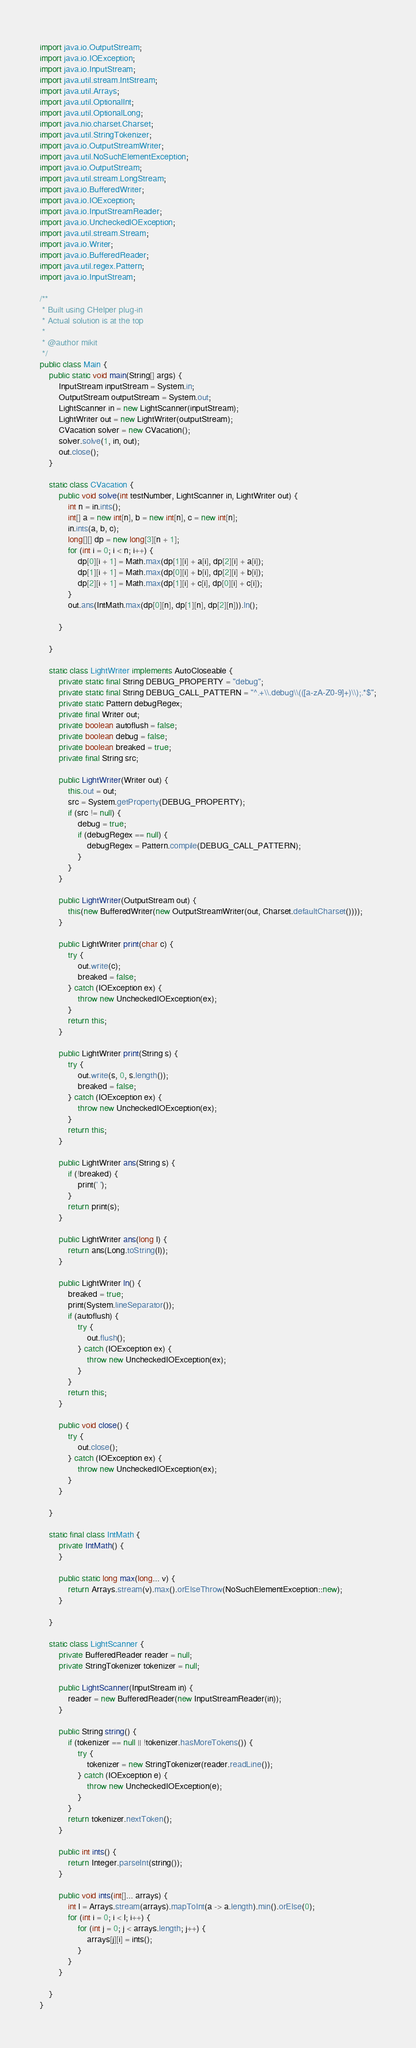<code> <loc_0><loc_0><loc_500><loc_500><_Java_>import java.io.OutputStream;
import java.io.IOException;
import java.io.InputStream;
import java.util.stream.IntStream;
import java.util.Arrays;
import java.util.OptionalInt;
import java.util.OptionalLong;
import java.nio.charset.Charset;
import java.util.StringTokenizer;
import java.io.OutputStreamWriter;
import java.util.NoSuchElementException;
import java.io.OutputStream;
import java.util.stream.LongStream;
import java.io.BufferedWriter;
import java.io.IOException;
import java.io.InputStreamReader;
import java.io.UncheckedIOException;
import java.util.stream.Stream;
import java.io.Writer;
import java.io.BufferedReader;
import java.util.regex.Pattern;
import java.io.InputStream;

/**
 * Built using CHelper plug-in
 * Actual solution is at the top
 *
 * @author mikit
 */
public class Main {
    public static void main(String[] args) {
        InputStream inputStream = System.in;
        OutputStream outputStream = System.out;
        LightScanner in = new LightScanner(inputStream);
        LightWriter out = new LightWriter(outputStream);
        CVacation solver = new CVacation();
        solver.solve(1, in, out);
        out.close();
    }

    static class CVacation {
        public void solve(int testNumber, LightScanner in, LightWriter out) {
            int n = in.ints();
            int[] a = new int[n], b = new int[n], c = new int[n];
            in.ints(a, b, c);
            long[][] dp = new long[3][n + 1];
            for (int i = 0; i < n; i++) {
                dp[0][i + 1] = Math.max(dp[1][i] + a[i], dp[2][i] + a[i]);
                dp[1][i + 1] = Math.max(dp[0][i] + b[i], dp[2][i] + b[i]);
                dp[2][i + 1] = Math.max(dp[1][i] + c[i], dp[0][i] + c[i]);
            }
            out.ans(IntMath.max(dp[0][n], dp[1][n], dp[2][n])).ln();

        }

    }

    static class LightWriter implements AutoCloseable {
        private static final String DEBUG_PROPERTY = "debug";
        private static final String DEBUG_CALL_PATTERN = "^.+\\.debug\\(([a-zA-Z0-9]+)\\);.*$";
        private static Pattern debugRegex;
        private final Writer out;
        private boolean autoflush = false;
        private boolean debug = false;
        private boolean breaked = true;
        private final String src;

        public LightWriter(Writer out) {
            this.out = out;
            src = System.getProperty(DEBUG_PROPERTY);
            if (src != null) {
                debug = true;
                if (debugRegex == null) {
                    debugRegex = Pattern.compile(DEBUG_CALL_PATTERN);
                }
            }
        }

        public LightWriter(OutputStream out) {
            this(new BufferedWriter(new OutputStreamWriter(out, Charset.defaultCharset())));
        }

        public LightWriter print(char c) {
            try {
                out.write(c);
                breaked = false;
            } catch (IOException ex) {
                throw new UncheckedIOException(ex);
            }
            return this;
        }

        public LightWriter print(String s) {
            try {
                out.write(s, 0, s.length());
                breaked = false;
            } catch (IOException ex) {
                throw new UncheckedIOException(ex);
            }
            return this;
        }

        public LightWriter ans(String s) {
            if (!breaked) {
                print(' ');
            }
            return print(s);
        }

        public LightWriter ans(long l) {
            return ans(Long.toString(l));
        }

        public LightWriter ln() {
            breaked = true;
            print(System.lineSeparator());
            if (autoflush) {
                try {
                    out.flush();
                } catch (IOException ex) {
                    throw new UncheckedIOException(ex);
                }
            }
            return this;
        }

        public void close() {
            try {
                out.close();
            } catch (IOException ex) {
                throw new UncheckedIOException(ex);
            }
        }

    }

    static final class IntMath {
        private IntMath() {
        }

        public static long max(long... v) {
            return Arrays.stream(v).max().orElseThrow(NoSuchElementException::new);
        }

    }

    static class LightScanner {
        private BufferedReader reader = null;
        private StringTokenizer tokenizer = null;

        public LightScanner(InputStream in) {
            reader = new BufferedReader(new InputStreamReader(in));
        }

        public String string() {
            if (tokenizer == null || !tokenizer.hasMoreTokens()) {
                try {
                    tokenizer = new StringTokenizer(reader.readLine());
                } catch (IOException e) {
                    throw new UncheckedIOException(e);
                }
            }
            return tokenizer.nextToken();
        }

        public int ints() {
            return Integer.parseInt(string());
        }

        public void ints(int[]... arrays) {
            int l = Arrays.stream(arrays).mapToInt(a -> a.length).min().orElse(0);
            for (int i = 0; i < l; i++) {
                for (int j = 0; j < arrays.length; j++) {
                    arrays[j][i] = ints();
                }
            }
        }

    }
}

</code> 